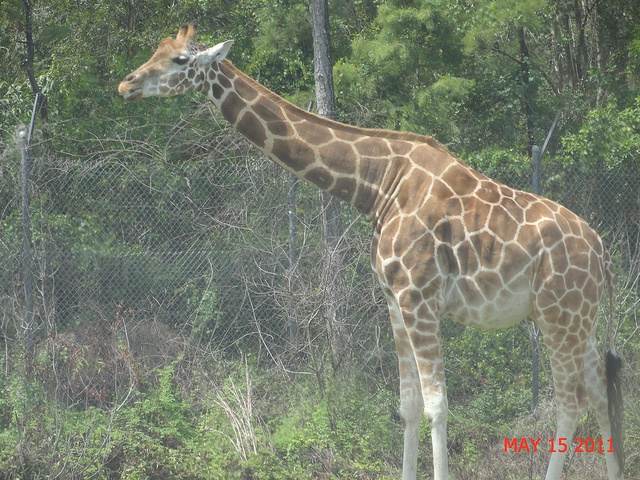Describe the objects in this image and their specific colors. I can see a giraffe in darkgreen, darkgray, and gray tones in this image. 